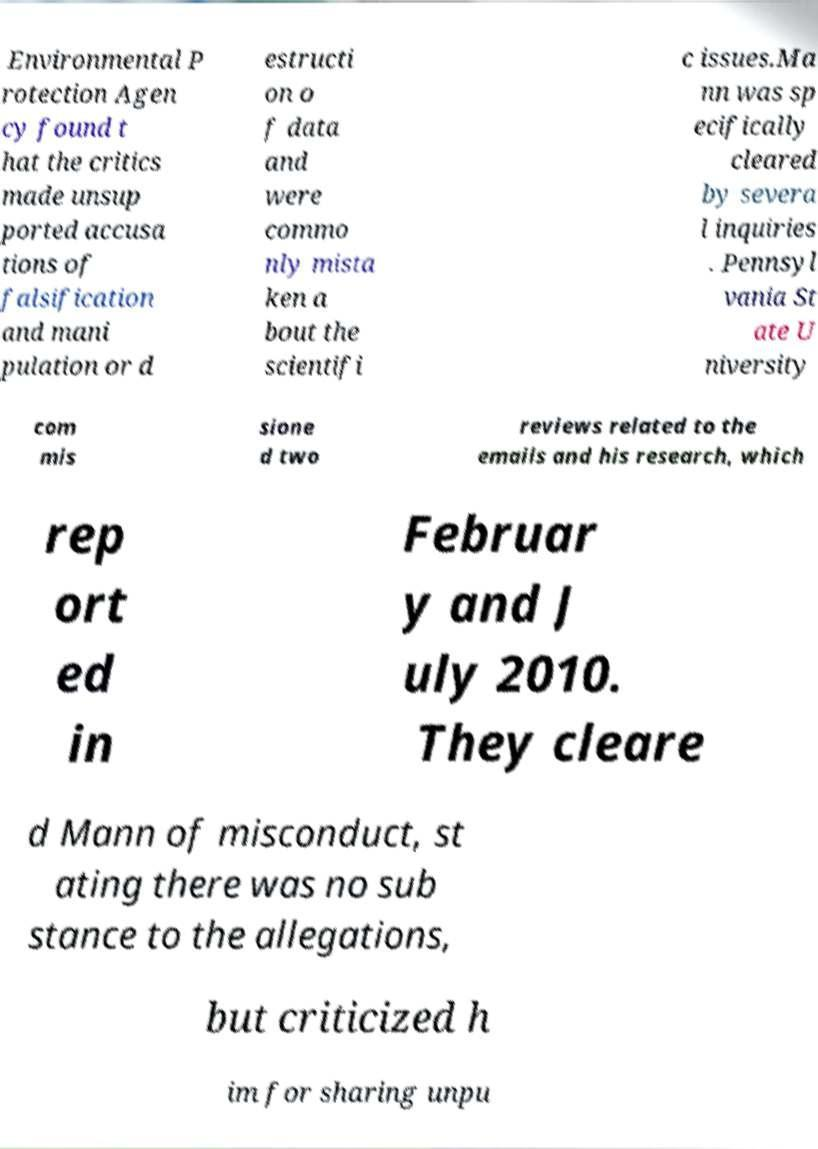Can you accurately transcribe the text from the provided image for me? Environmental P rotection Agen cy found t hat the critics made unsup ported accusa tions of falsification and mani pulation or d estructi on o f data and were commo nly mista ken a bout the scientifi c issues.Ma nn was sp ecifically cleared by severa l inquiries . Pennsyl vania St ate U niversity com mis sione d two reviews related to the emails and his research, which rep ort ed in Februar y and J uly 2010. They cleare d Mann of misconduct, st ating there was no sub stance to the allegations, but criticized h im for sharing unpu 